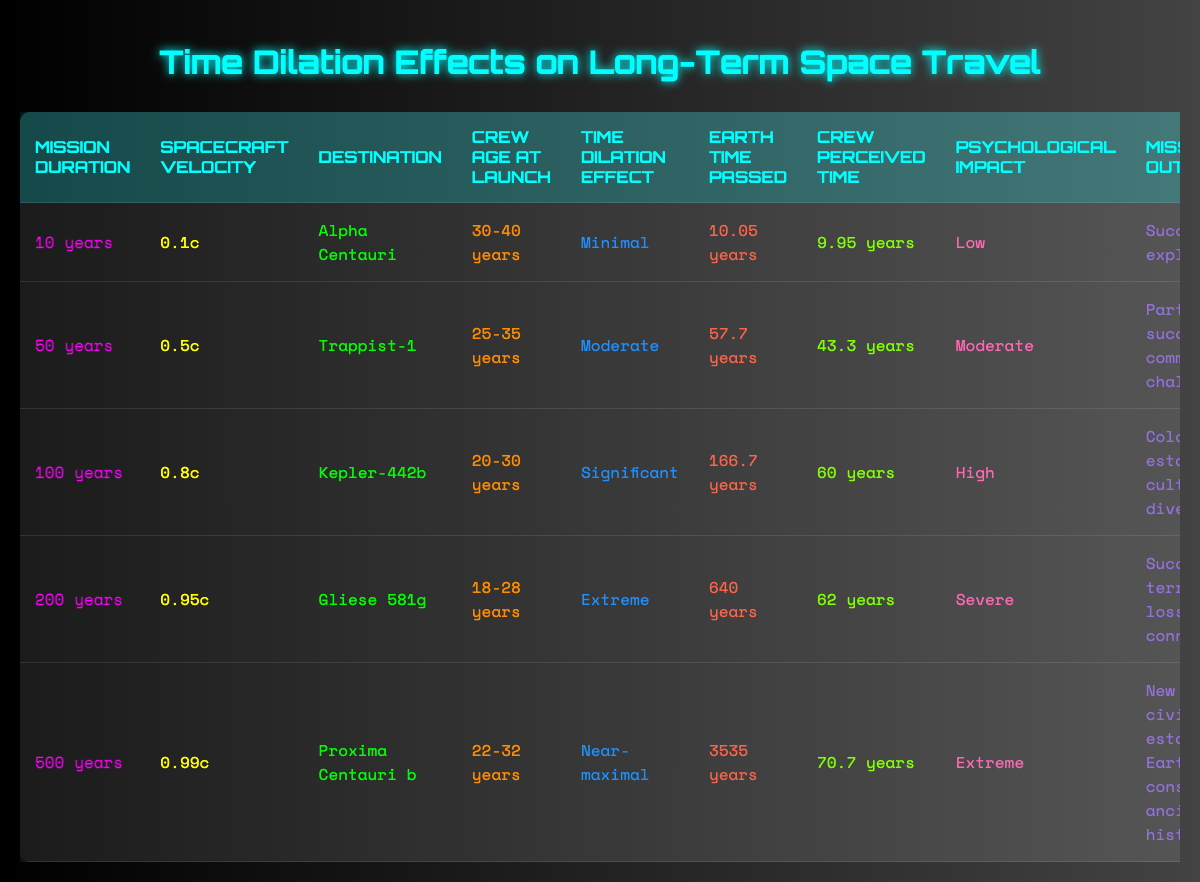What is the time dilation effect for the mission to Alpha Centauri? According to the table, the time dilation effect for the mission to Alpha Centauri, which has a duration of 10 years at a velocity of 0.1c, is classified as "Minimal."
Answer: Minimal How much Earth time passes for the mission to Kepler-442b? The table indicates that for the mission to Kepler-442b, which lasts 100 years at a velocity of 0.8c, the Earth time passed is 166.7 years.
Answer: 166.7 years Which mission has a significant psychological impact on the crew? By examining the table, the mission to Kepler-442b, with a high psychological impact, corresponds to a mission duration of 100 years and a velocity of 0.8c.
Answer: Kepler-442b What is the average crew perceived time across all missions listed? To find the average crew perceived time, sum the crew perceived times: (9.95 + 43.3 + 60 + 62 + 70.7) = 246.02. There are 5 missions, so the average crew perceived time is 246.02/5 = 49.204 years.
Answer: Approximately 49.2 years Is the mission outcome for the 500-year mission a successful terraforming? According to the table, the outcome for the 500-year mission to Proxima Centauri b is "New civilization established, Earth considered ancient history," which does not confirm a successful terraforming.
Answer: No What is the difference in Earth time passed between the 200-year mission and the 100-year mission? The Earth time for the 200-year mission to Gliese 581g is 640 years, and for the 100-year mission to Kepler-442b, it is 166.7 years. Therefore, the difference is 640 - 166.7 = 473.3 years.
Answer: 473.3 years Can you find a mission where the crew age at launch is higher than 30 years? Referring to the table, the missions to Trappist-1 (crew age of 25-35), and Proxima Centauri b (crew age of 22-32) are both under or exactly 30, but the mission to Kepler-442b with a crew age of 20-30 has lower than 30. The mission to Gliese 581g has a crew age of 18-28, so none meet over 30.
Answer: No What was the crew's psychological impact on the 50-year mission? The table specifies that for the 50-year mission to Trappist-1, the psychological impact was at a "Moderate" level.
Answer: Moderate What is the spacecraft velocity of the mission with the extreme time dilation effect? The table shows the mission to Gliese 581g, which has an extreme time dilation effect, at a spacecraft velocity of 0.95c.
Answer: 0.95c 